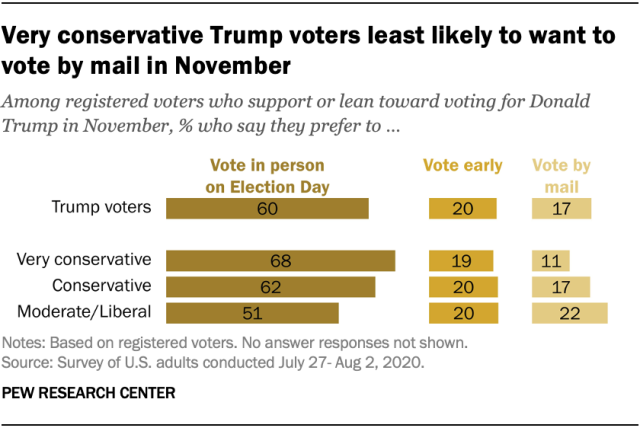Identify some key points in this picture. The value of the "Vote early" bar for Trump voters is 20. Out of the values in the "Vote early" bars, three of them have the same value. 